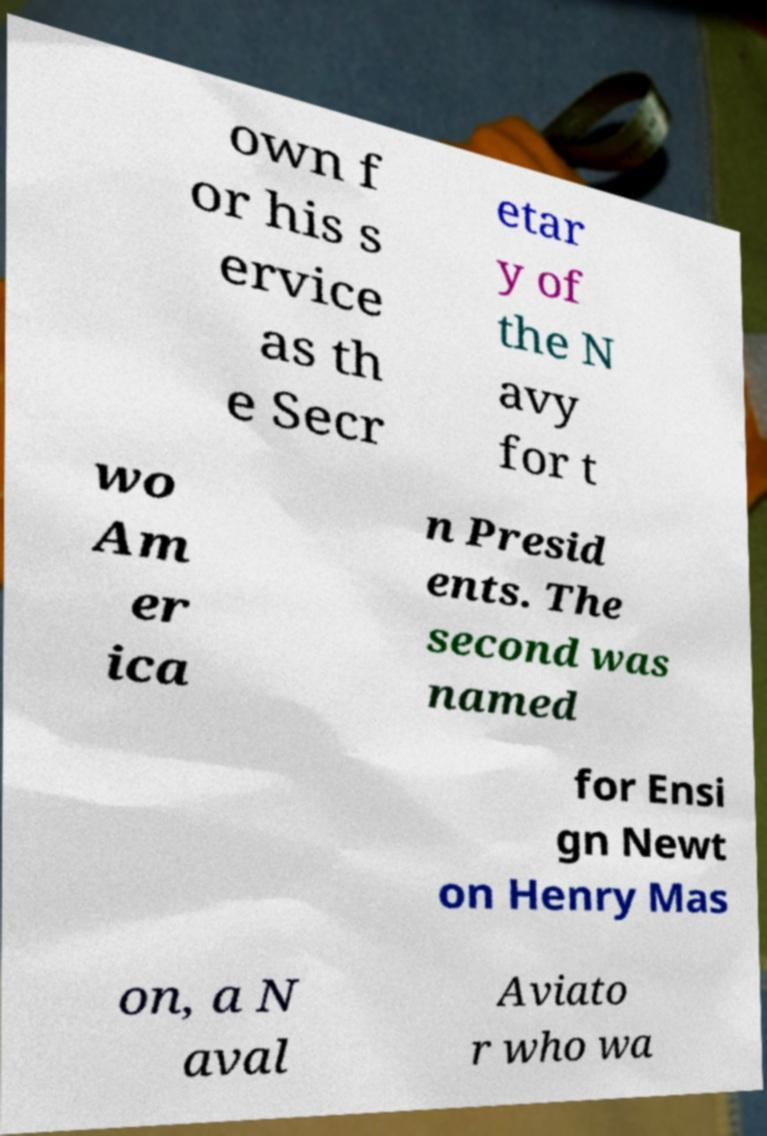Can you read and provide the text displayed in the image?This photo seems to have some interesting text. Can you extract and type it out for me? own f or his s ervice as th e Secr etar y of the N avy for t wo Am er ica n Presid ents. The second was named for Ensi gn Newt on Henry Mas on, a N aval Aviato r who wa 